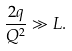<formula> <loc_0><loc_0><loc_500><loc_500>\frac { 2 q } { Q ^ { 2 } } \gg L .</formula> 